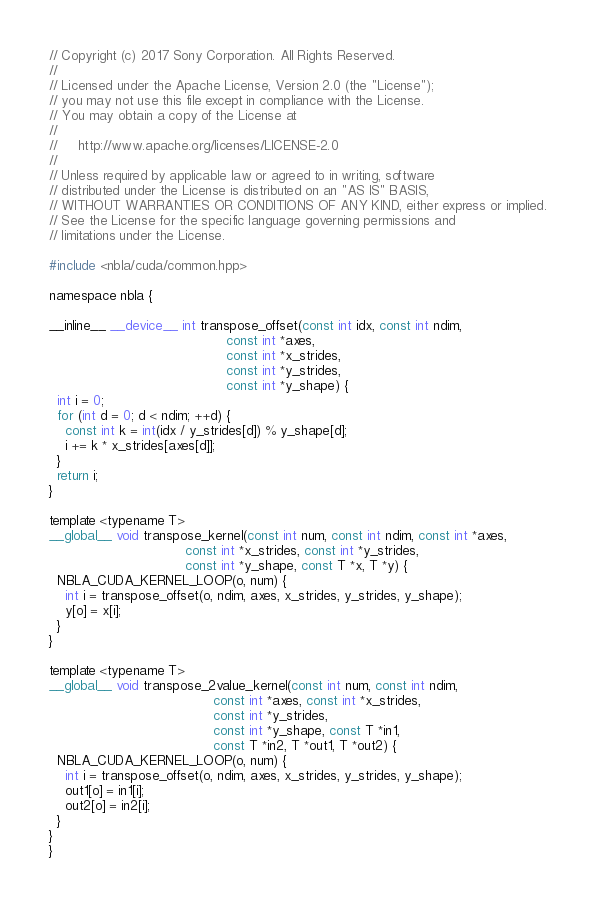Convert code to text. <code><loc_0><loc_0><loc_500><loc_500><_Cuda_>// Copyright (c) 2017 Sony Corporation. All Rights Reserved.
//
// Licensed under the Apache License, Version 2.0 (the "License");
// you may not use this file except in compliance with the License.
// You may obtain a copy of the License at
//
//     http://www.apache.org/licenses/LICENSE-2.0
//
// Unless required by applicable law or agreed to in writing, software
// distributed under the License is distributed on an "AS IS" BASIS,
// WITHOUT WARRANTIES OR CONDITIONS OF ANY KIND, either express or implied.
// See the License for the specific language governing permissions and
// limitations under the License.

#include <nbla/cuda/common.hpp>

namespace nbla {

__inline__ __device__ int transpose_offset(const int idx, const int ndim,
                                           const int *axes,
                                           const int *x_strides,
                                           const int *y_strides,
                                           const int *y_shape) {
  int i = 0;
  for (int d = 0; d < ndim; ++d) {
    const int k = int(idx / y_strides[d]) % y_shape[d];
    i += k * x_strides[axes[d]];
  }
  return i;
}

template <typename T>
__global__ void transpose_kernel(const int num, const int ndim, const int *axes,
                                 const int *x_strides, const int *y_strides,
                                 const int *y_shape, const T *x, T *y) {
  NBLA_CUDA_KERNEL_LOOP(o, num) {
    int i = transpose_offset(o, ndim, axes, x_strides, y_strides, y_shape);
    y[o] = x[i];
  }
}

template <typename T>
__global__ void transpose_2value_kernel(const int num, const int ndim,
                                        const int *axes, const int *x_strides,
                                        const int *y_strides,
                                        const int *y_shape, const T *in1,
                                        const T *in2, T *out1, T *out2) {
  NBLA_CUDA_KERNEL_LOOP(o, num) {
    int i = transpose_offset(o, ndim, axes, x_strides, y_strides, y_shape);
    out1[o] = in1[i];
    out2[o] = in2[i];
  }
}
}
</code> 